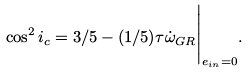<formula> <loc_0><loc_0><loc_500><loc_500>\cos ^ { 2 } i _ { c } = 3 / 5 - ( 1 / 5 ) \tau \dot { \omega } _ { G R } \Big { | } _ { e _ { i n } = 0 } .</formula> 